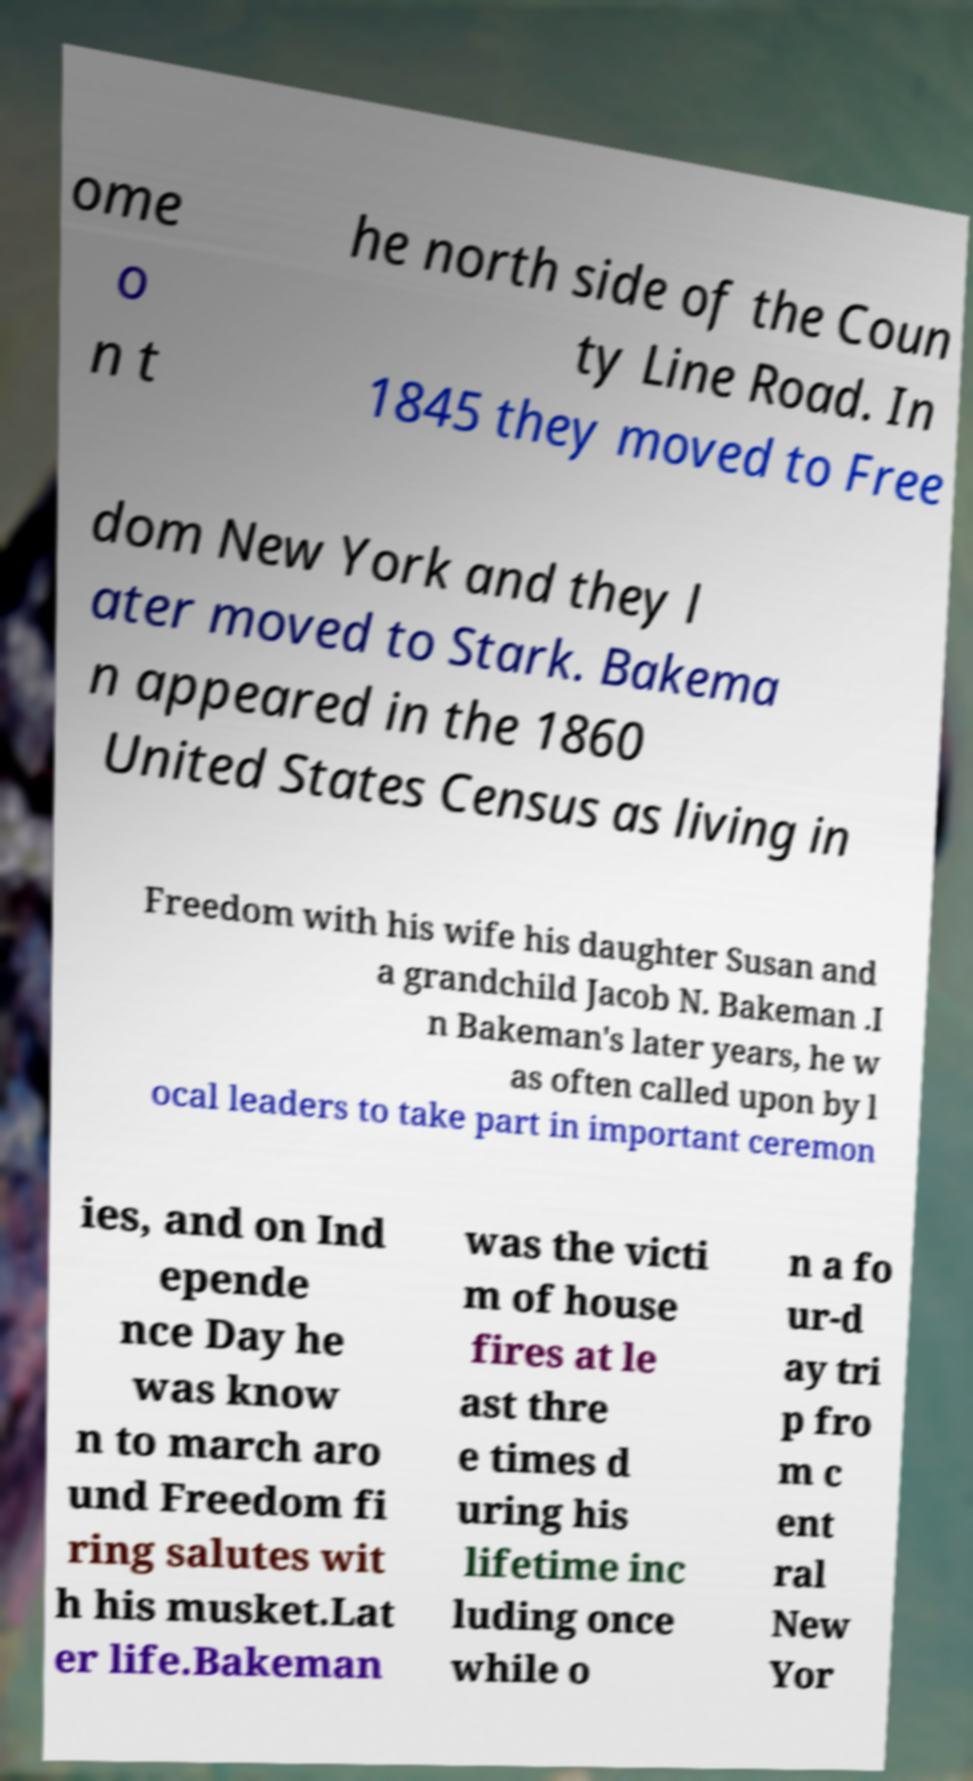I need the written content from this picture converted into text. Can you do that? ome o n t he north side of the Coun ty Line Road. In 1845 they moved to Free dom New York and they l ater moved to Stark. Bakema n appeared in the 1860 United States Census as living in Freedom with his wife his daughter Susan and a grandchild Jacob N. Bakeman .I n Bakeman's later years, he w as often called upon by l ocal leaders to take part in important ceremon ies, and on Ind epende nce Day he was know n to march aro und Freedom fi ring salutes wit h his musket.Lat er life.Bakeman was the victi m of house fires at le ast thre e times d uring his lifetime inc luding once while o n a fo ur-d ay tri p fro m c ent ral New Yor 